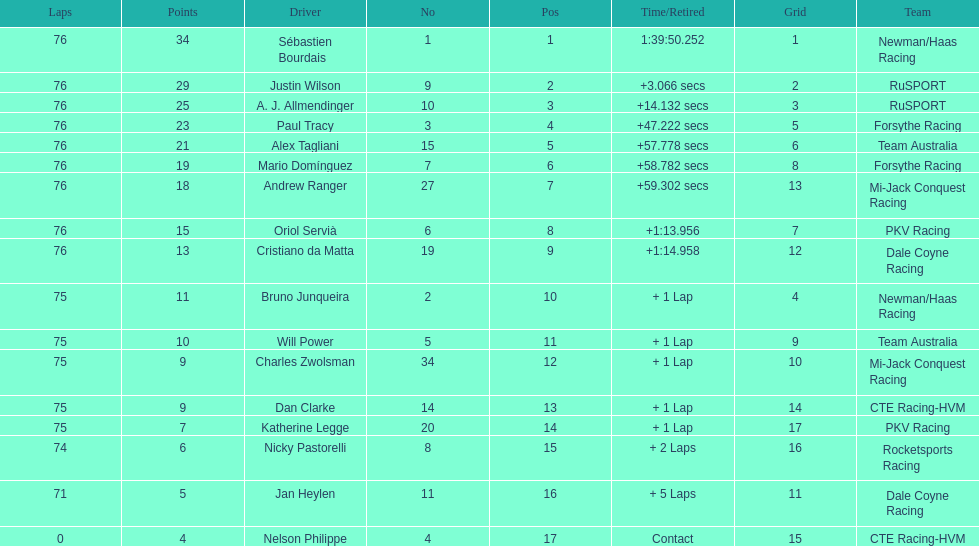What driver earned the most points? Sebastien Bourdais. 